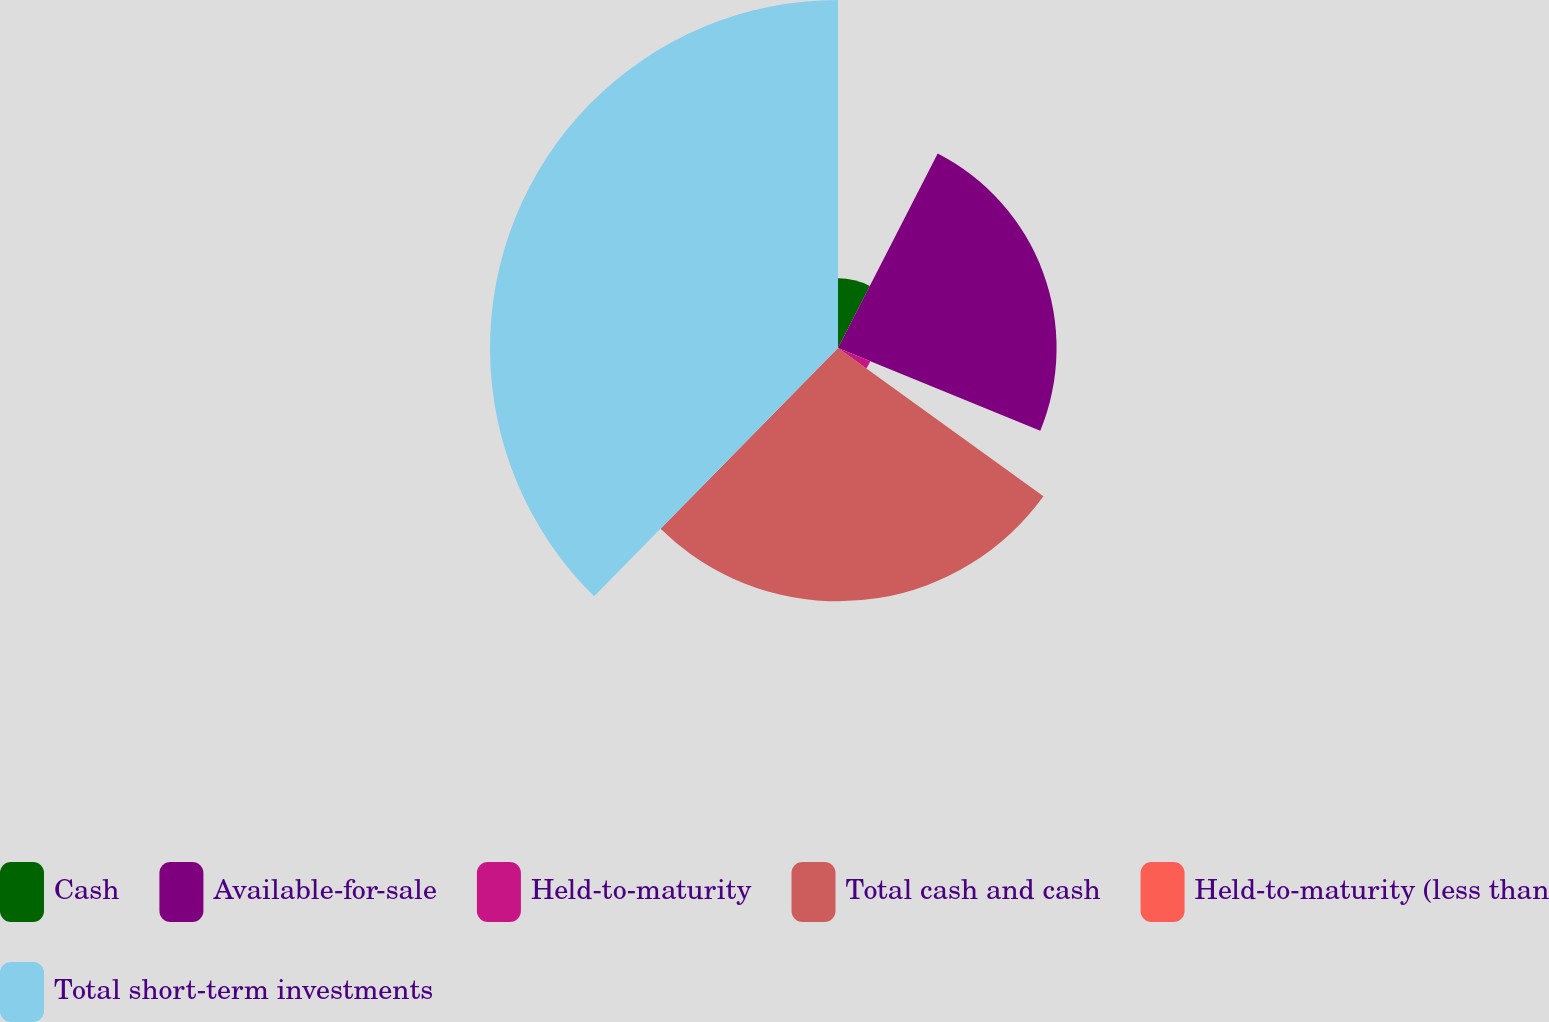<chart> <loc_0><loc_0><loc_500><loc_500><pie_chart><fcel>Cash<fcel>Available-for-sale<fcel>Held-to-maturity<fcel>Total cash and cash<fcel>Held-to-maturity (less than<fcel>Total short-term investments<nl><fcel>7.54%<fcel>23.64%<fcel>3.77%<fcel>27.4%<fcel>0.01%<fcel>37.64%<nl></chart> 